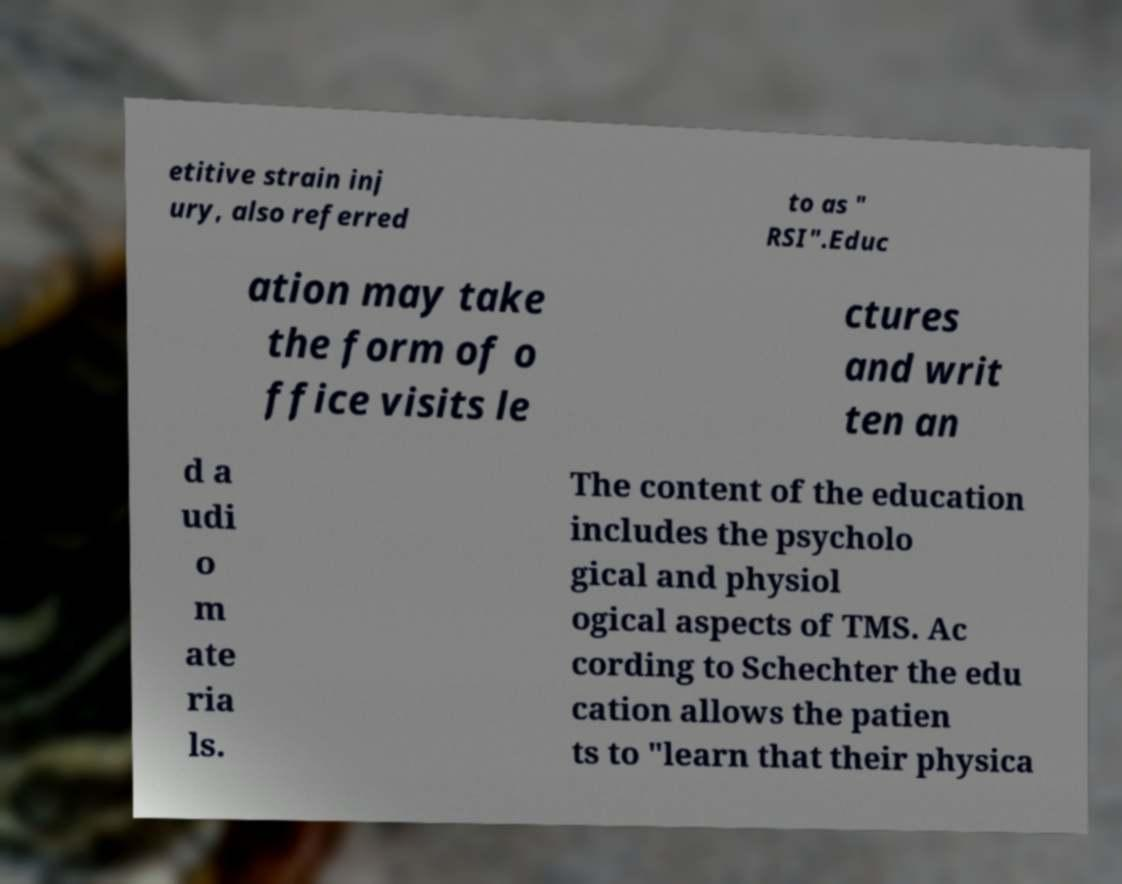Can you accurately transcribe the text from the provided image for me? etitive strain inj ury, also referred to as " RSI".Educ ation may take the form of o ffice visits le ctures and writ ten an d a udi o m ate ria ls. The content of the education includes the psycholo gical and physiol ogical aspects of TMS. Ac cording to Schechter the edu cation allows the patien ts to "learn that their physica 